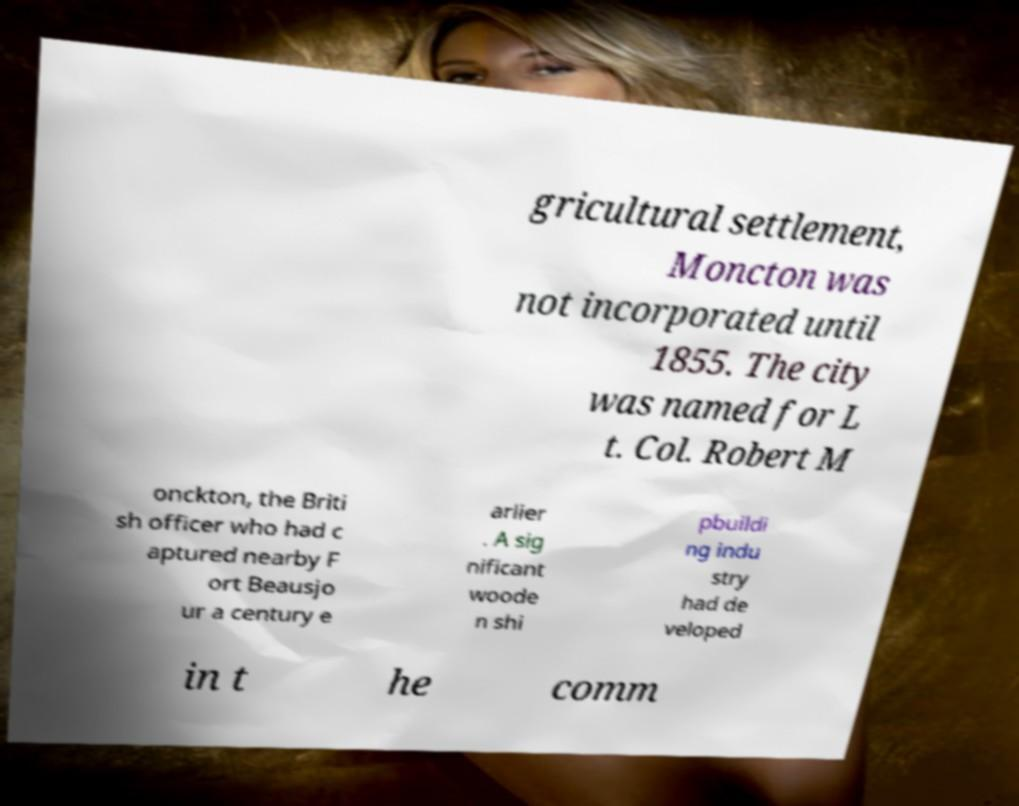For documentation purposes, I need the text within this image transcribed. Could you provide that? gricultural settlement, Moncton was not incorporated until 1855. The city was named for L t. Col. Robert M onckton, the Briti sh officer who had c aptured nearby F ort Beausjo ur a century e arlier . A sig nificant woode n shi pbuildi ng indu stry had de veloped in t he comm 